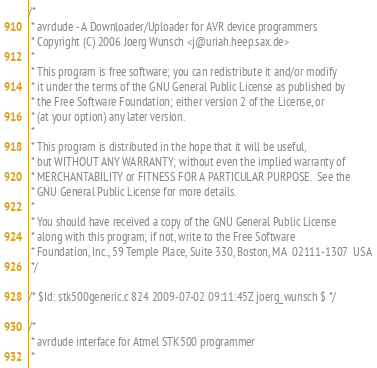Convert code to text. <code><loc_0><loc_0><loc_500><loc_500><_C_>/*
 * avrdude - A Downloader/Uploader for AVR device programmers
 * Copyright (C) 2006 Joerg Wunsch <j@uriah.heep.sax.de>
 *
 * This program is free software; you can redistribute it and/or modify
 * it under the terms of the GNU General Public License as published by
 * the Free Software Foundation; either version 2 of the License, or
 * (at your option) any later version.
 *
 * This program is distributed in the hope that it will be useful,
 * but WITHOUT ANY WARRANTY; without even the implied warranty of
 * MERCHANTABILITY or FITNESS FOR A PARTICULAR PURPOSE.  See the
 * GNU General Public License for more details.
 *
 * You should have received a copy of the GNU General Public License
 * along with this program; if not, write to the Free Software
 * Foundation, Inc., 59 Temple Place, Suite 330, Boston, MA  02111-1307  USA
 */

/* $Id: stk500generic.c 824 2009-07-02 09:11:45Z joerg_wunsch $ */

/*
 * avrdude interface for Atmel STK500 programmer
 *</code> 